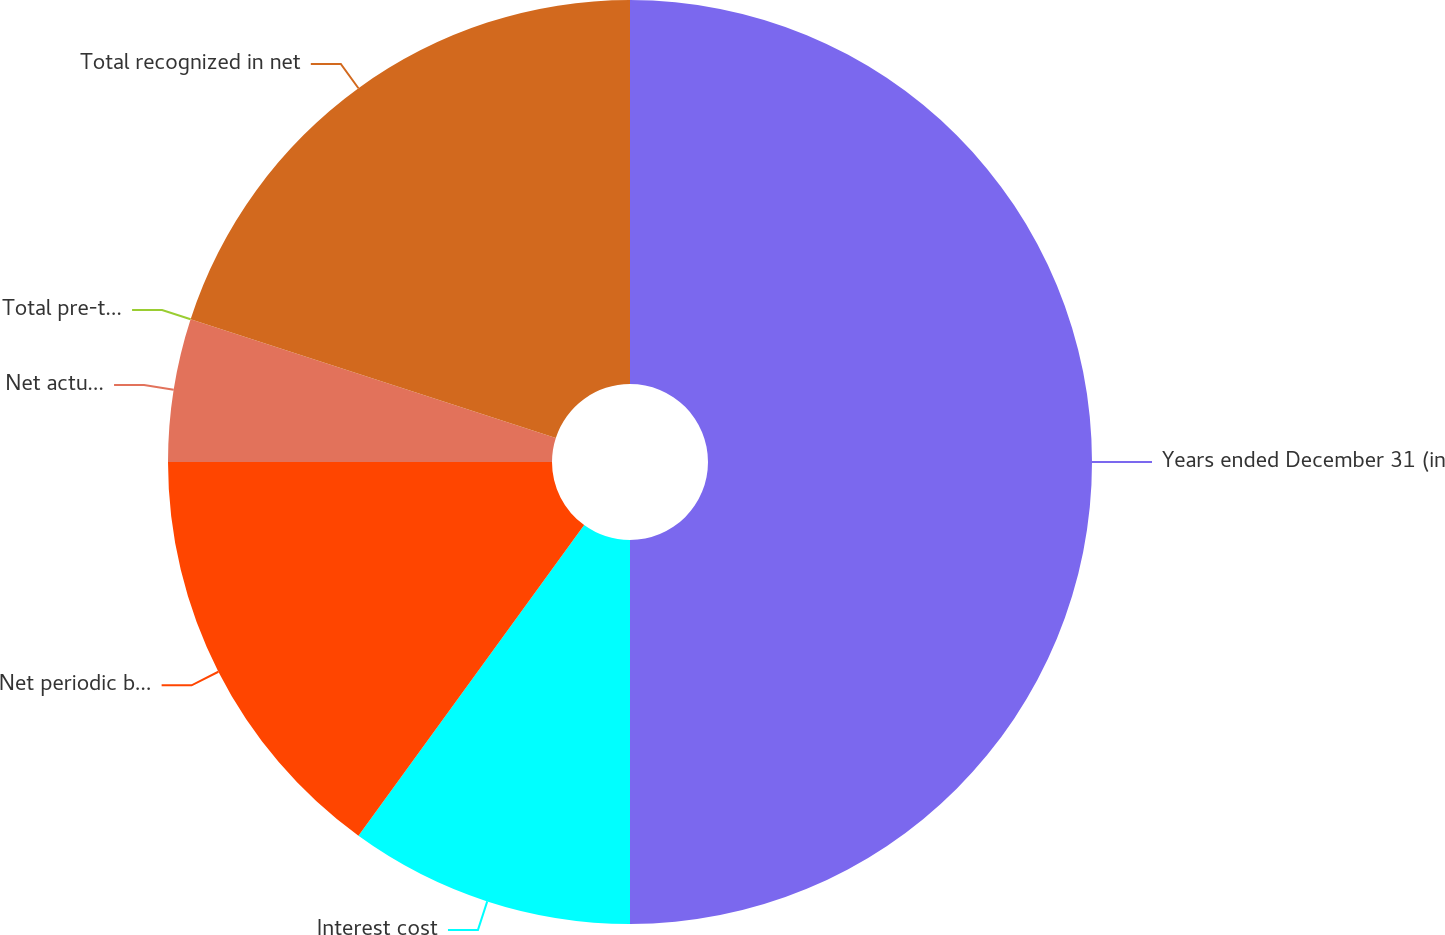<chart> <loc_0><loc_0><loc_500><loc_500><pie_chart><fcel>Years ended December 31 (in<fcel>Interest cost<fcel>Net periodic benefit (income)<fcel>Net actuarial loss (gain)<fcel>Total pre-tax changes<fcel>Total recognized in net<nl><fcel>50.0%<fcel>10.0%<fcel>15.0%<fcel>5.0%<fcel>0.0%<fcel>20.0%<nl></chart> 